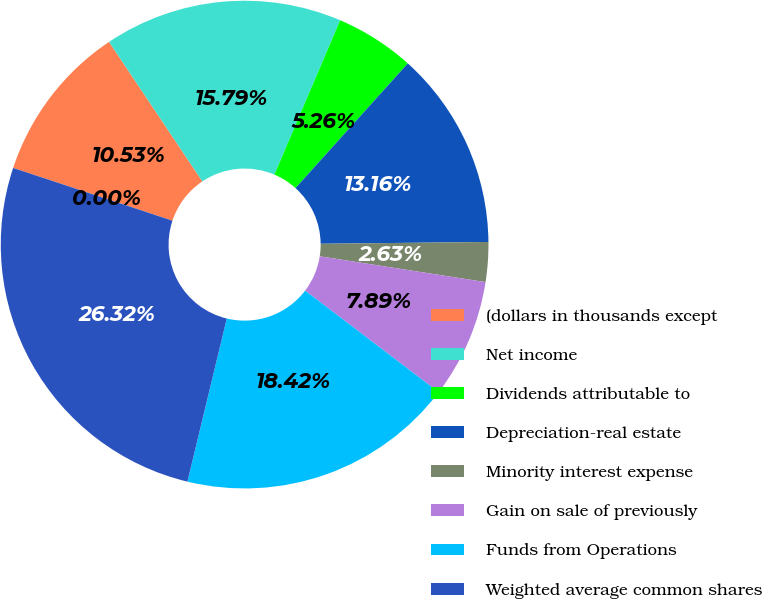<chart> <loc_0><loc_0><loc_500><loc_500><pie_chart><fcel>(dollars in thousands except<fcel>Net income<fcel>Dividends attributable to<fcel>Depreciation-real estate<fcel>Minority interest expense<fcel>Gain on sale of previously<fcel>Funds from Operations<fcel>Weighted average common shares<fcel>FFO per common share-diluted<nl><fcel>10.53%<fcel>15.79%<fcel>5.26%<fcel>13.16%<fcel>2.63%<fcel>7.89%<fcel>18.42%<fcel>26.32%<fcel>0.0%<nl></chart> 